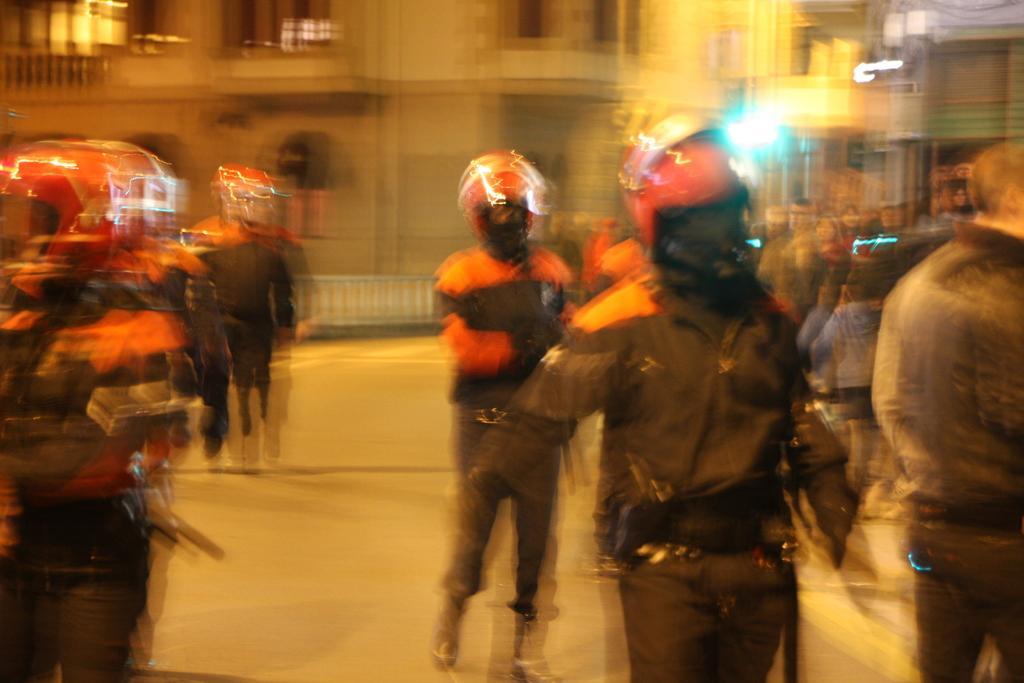Could you give a brief overview of what you see in this image? In this picture I can observe some people on the road. They are wearing helmets. In the background I can observe building. The entire picture is blurred. 